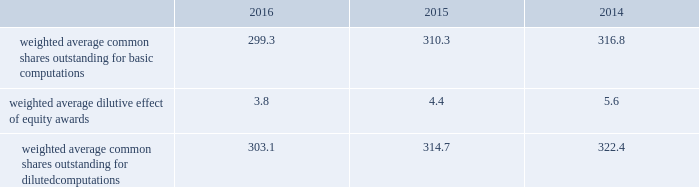Benefits as an increase to earnings of $ 152 million ( $ 0.50 per share ) during the year ended december 31 , 2016 .
Additionally , we recognized additional income tax benefits as an increase to operating cash flows of $ 152 million during the year ended december 31 , 2016 .
The new accounting standard did not impact any periods prior to january 1 , 2016 , as we applied the changes in the asu on a prospective basis .
In september 2015 , the fasb issued asu no .
2015-16 , business combinations ( topic 805 ) , which simplifies the accounting for adjustments made to preliminary amounts recognized in a business combination by eliminating the requirement to retrospectively account for those adjustments .
Instead , adjustments will be recognized in the period in which the adjustments are determined , including the effect on earnings of any amounts that would have been recorded in previous periods if the accounting had been completed at the acquisition date .
We adopted the asu on january 1 , 2016 and are prospectively applying the asu to business combination adjustments identified after the date of adoption .
In november 2015 , the fasb issued asu no .
2015-17 , income taxes ( topic 740 ) , which simplifies the presentation of deferred income taxes and requires that deferred tax assets and liabilities , as well as any related valuation allowance , be classified as noncurrent in our consolidated balance sheets .
We applied the provisions of the asu retrospectively and reclassified approximately $ 1.6 billion from current to noncurrent assets and approximately $ 140 million from current to noncurrent liabilities in our consolidated balance sheet as of december 31 , 2015 .
Note 2 2013 earnings per share the weighted average number of shares outstanding used to compute earnings per common share were as follows ( in millions ) : .
We compute basic and diluted earnings per common share by dividing net earnings by the respective weighted average number of common shares outstanding for the periods presented .
Our calculation of diluted earnings per common share also includes the dilutive effects for the assumed vesting of outstanding restricted stock units and exercise of outstanding stock options based on the treasury stock method .
There were no anti-dilutive equity awards for the years ended december 31 , 2016 , 2015 and 2014 .
Note 3 2013 acquisitions and divestitures acquisitions acquisition of sikorsky aircraft corporation on november 6 , 2015 , we completed the acquisition of sikorsky aircraft corporation and certain affiliated companies ( collectively 201csikorsky 201d ) from united technologies corporation ( utc ) and certain of utc 2019s subsidiaries .
The purchase price of the acquisition was $ 9.0 billion , net of cash acquired .
As a result of the acquisition , sikorsky became a wholly- owned subsidiary of ours .
Sikorsky is a global company primarily engaged in the research , design , development , manufacture and support of military and commercial helicopters .
Sikorsky 2019s products include military helicopters such as the black hawk , seahawk , ch-53k , h-92 ; and commercial helicopters such as the s-76 and s-92 .
The acquisition enables us to extend our core business into the military and commercial rotary wing markets , allowing us to strengthen our position in the aerospace and defense industry .
Further , this acquisition will expand our presence in commercial and international markets .
Sikorsky has been aligned under our rms business segment .
To fund the $ 9.0 billion acquisition price , we utilized $ 6.0 billion of proceeds borrowed under a temporary 364-day revolving credit facility ( the 364-day facility ) , $ 2.0 billion of cash on hand and $ 1.0 billion from the issuance of commercial paper .
In the fourth quarter of 2015 , we repaid all outstanding borrowings under the 364-day facility with the proceeds from the issuance of $ 7.0 billion of fixed interest-rate long-term notes in a public offering ( the november 2015 notes ) .
In the fourth quarter of 2015 , we also repaid the $ 1.0 billion in commercial paper borrowings ( see 201cnote 10 2013 debt 201d ) . .
What was the change in millions of weighted average common shares outstanding for diluted computations from 2015 to 2016? 
Computations: (303.1 - 314.7)
Answer: -11.6. Benefits as an increase to earnings of $ 152 million ( $ 0.50 per share ) during the year ended december 31 , 2016 .
Additionally , we recognized additional income tax benefits as an increase to operating cash flows of $ 152 million during the year ended december 31 , 2016 .
The new accounting standard did not impact any periods prior to january 1 , 2016 , as we applied the changes in the asu on a prospective basis .
In september 2015 , the fasb issued asu no .
2015-16 , business combinations ( topic 805 ) , which simplifies the accounting for adjustments made to preliminary amounts recognized in a business combination by eliminating the requirement to retrospectively account for those adjustments .
Instead , adjustments will be recognized in the period in which the adjustments are determined , including the effect on earnings of any amounts that would have been recorded in previous periods if the accounting had been completed at the acquisition date .
We adopted the asu on january 1 , 2016 and are prospectively applying the asu to business combination adjustments identified after the date of adoption .
In november 2015 , the fasb issued asu no .
2015-17 , income taxes ( topic 740 ) , which simplifies the presentation of deferred income taxes and requires that deferred tax assets and liabilities , as well as any related valuation allowance , be classified as noncurrent in our consolidated balance sheets .
We applied the provisions of the asu retrospectively and reclassified approximately $ 1.6 billion from current to noncurrent assets and approximately $ 140 million from current to noncurrent liabilities in our consolidated balance sheet as of december 31 , 2015 .
Note 2 2013 earnings per share the weighted average number of shares outstanding used to compute earnings per common share were as follows ( in millions ) : .
We compute basic and diluted earnings per common share by dividing net earnings by the respective weighted average number of common shares outstanding for the periods presented .
Our calculation of diluted earnings per common share also includes the dilutive effects for the assumed vesting of outstanding restricted stock units and exercise of outstanding stock options based on the treasury stock method .
There were no anti-dilutive equity awards for the years ended december 31 , 2016 , 2015 and 2014 .
Note 3 2013 acquisitions and divestitures acquisitions acquisition of sikorsky aircraft corporation on november 6 , 2015 , we completed the acquisition of sikorsky aircraft corporation and certain affiliated companies ( collectively 201csikorsky 201d ) from united technologies corporation ( utc ) and certain of utc 2019s subsidiaries .
The purchase price of the acquisition was $ 9.0 billion , net of cash acquired .
As a result of the acquisition , sikorsky became a wholly- owned subsidiary of ours .
Sikorsky is a global company primarily engaged in the research , design , development , manufacture and support of military and commercial helicopters .
Sikorsky 2019s products include military helicopters such as the black hawk , seahawk , ch-53k , h-92 ; and commercial helicopters such as the s-76 and s-92 .
The acquisition enables us to extend our core business into the military and commercial rotary wing markets , allowing us to strengthen our position in the aerospace and defense industry .
Further , this acquisition will expand our presence in commercial and international markets .
Sikorsky has been aligned under our rms business segment .
To fund the $ 9.0 billion acquisition price , we utilized $ 6.0 billion of proceeds borrowed under a temporary 364-day revolving credit facility ( the 364-day facility ) , $ 2.0 billion of cash on hand and $ 1.0 billion from the issuance of commercial paper .
In the fourth quarter of 2015 , we repaid all outstanding borrowings under the 364-day facility with the proceeds from the issuance of $ 7.0 billion of fixed interest-rate long-term notes in a public offering ( the november 2015 notes ) .
In the fourth quarter of 2015 , we also repaid the $ 1.0 billion in commercial paper borrowings ( see 201cnote 10 2013 debt 201d ) . .
What were the average number of weighted average common shares outstanding for diluted computations in millions from 2014 to 2016? 
Computations: table_average(weighted average common shares outstanding for dilutedcomputations, none)
Answer: 313.4. 